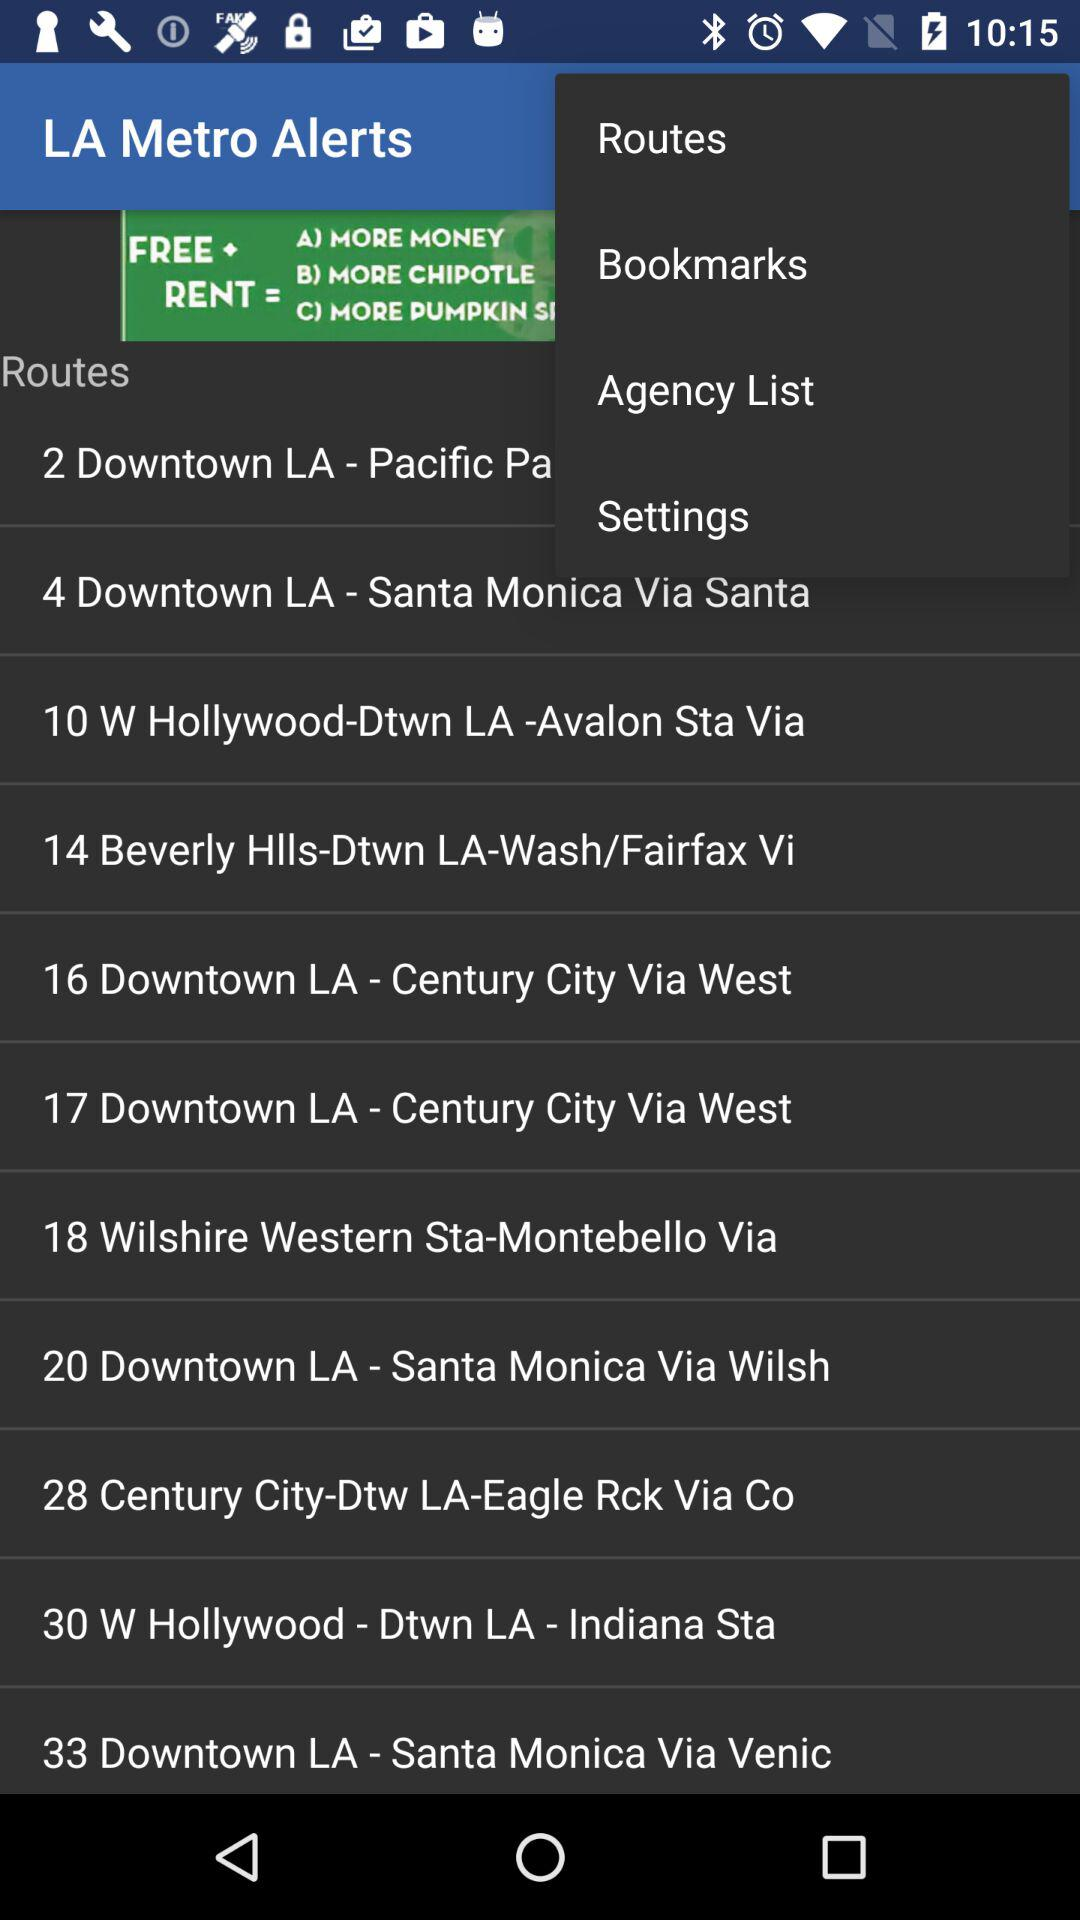What routes are mentioned in "LA Metro Alerts"? The routes are "4 Downtown LA - Santa Monica Via Santa", "10 W Hollywood-Dtwn LA -Avalon Sta Via", "14 Beverly Hlls-Dtwn LA-Wash/Fairfax Vi", "16 Downtown LA - Century City Via West", "17 Downtown LA - Century City Via West", "18 Wilshire Western Sta-Montebello Via", "20 Downtown LA - Santa Monica Via Wilsh", "28 Century City-Dtw LA-Eagle Rck Via Co", "30 W Hollywood - Dtwn LA - Indiana Sta" and "33 Downtown LA - Santa Monica Via Venic". 